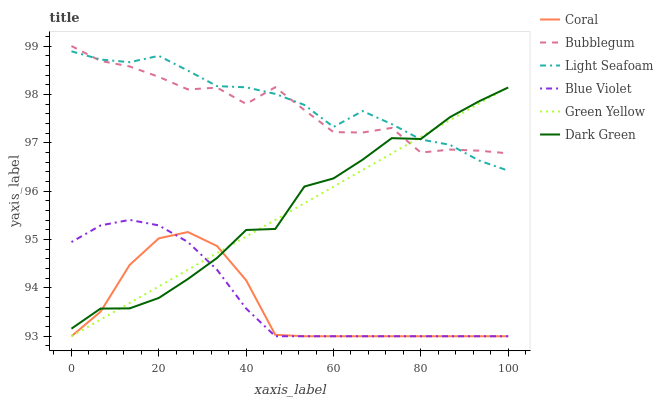Does Bubblegum have the minimum area under the curve?
Answer yes or no. No. Does Bubblegum have the maximum area under the curve?
Answer yes or no. No. Is Coral the smoothest?
Answer yes or no. No. Is Coral the roughest?
Answer yes or no. No. Does Bubblegum have the lowest value?
Answer yes or no. No. Does Coral have the highest value?
Answer yes or no. No. Is Coral less than Bubblegum?
Answer yes or no. Yes. Is Light Seafoam greater than Blue Violet?
Answer yes or no. Yes. Does Coral intersect Bubblegum?
Answer yes or no. No. 